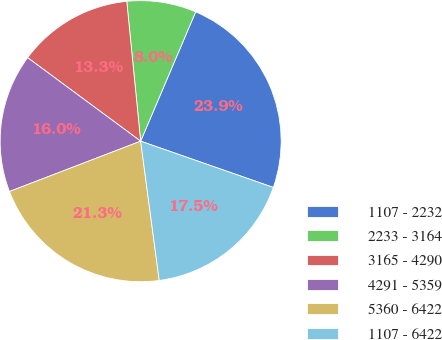Convert chart to OTSL. <chart><loc_0><loc_0><loc_500><loc_500><pie_chart><fcel>1107 - 2232<fcel>2233 - 3164<fcel>3165 - 4290<fcel>4291 - 5359<fcel>5360 - 6422<fcel>1107 - 6422<nl><fcel>23.94%<fcel>7.98%<fcel>13.3%<fcel>15.96%<fcel>21.28%<fcel>17.55%<nl></chart> 